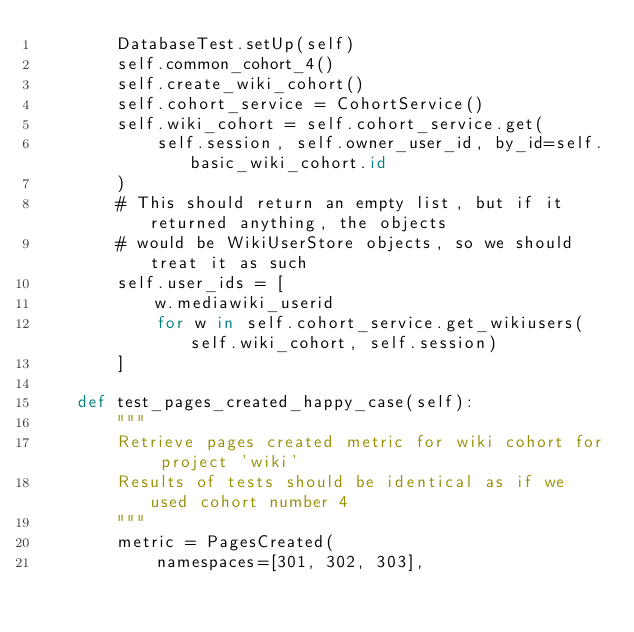<code> <loc_0><loc_0><loc_500><loc_500><_Python_>        DatabaseTest.setUp(self)
        self.common_cohort_4()
        self.create_wiki_cohort()
        self.cohort_service = CohortService()
        self.wiki_cohort = self.cohort_service.get(
            self.session, self.owner_user_id, by_id=self.basic_wiki_cohort.id
        )
        # This should return an empty list, but if it returned anything, the objects
        # would be WikiUserStore objects, so we should treat it as such
        self.user_ids = [
            w.mediawiki_userid
            for w in self.cohort_service.get_wikiusers(self.wiki_cohort, self.session)
        ]

    def test_pages_created_happy_case(self):
        """
        Retrieve pages created metric for wiki cohort for project 'wiki'
        Results of tests should be identical as if we used cohort number 4
        """
        metric = PagesCreated(
            namespaces=[301, 302, 303],</code> 